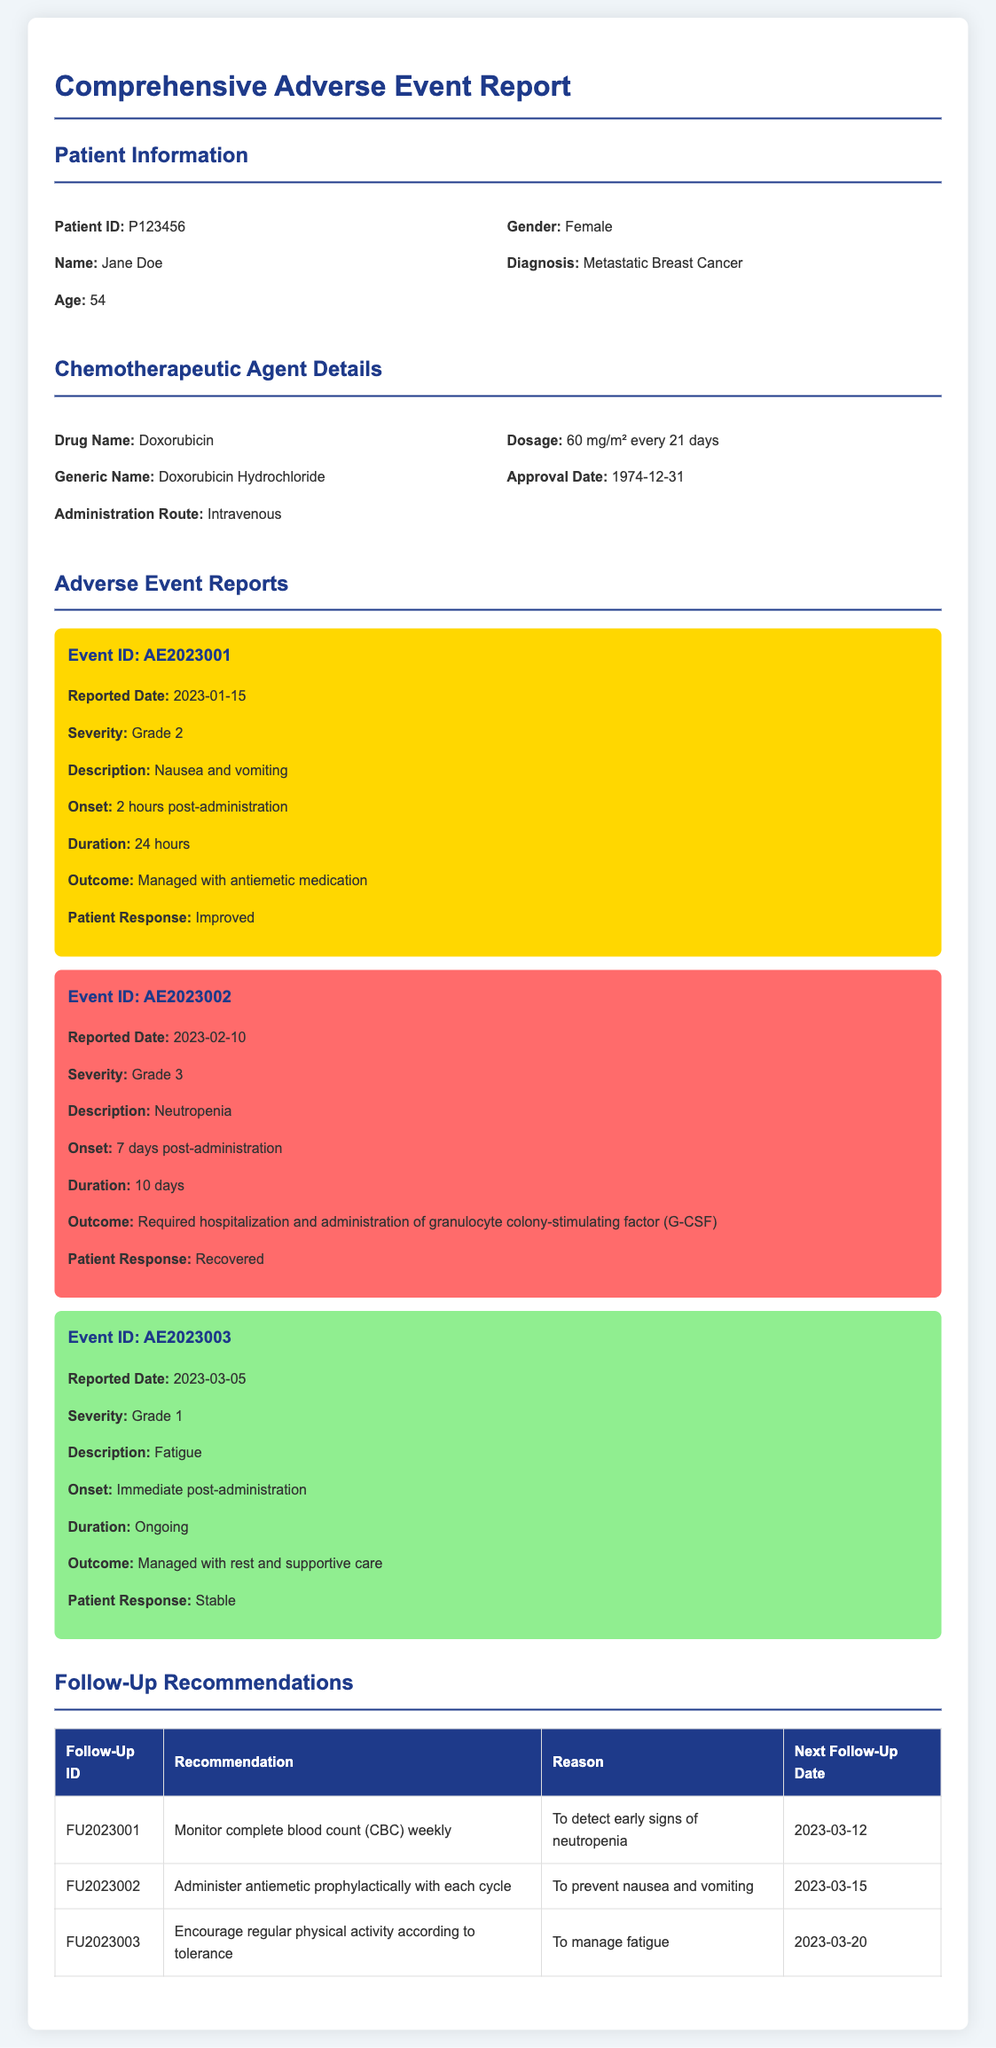What is the patient ID? The patient ID is a unique identifier for the patient, listed under Patient Information.
Answer: P123456 What is the drug name? The drug name is specified under the Chemotherapeutic Agent Details section.
Answer: Doxorubicin What was the reported date of the first adverse event? The reported date is found in the Adverse Event Reports section for the first event.
Answer: 2023-01-15 What is the duration of the neutropenia event? The duration can be found in the description of the neutropenia event under Adverse Event Reports.
Answer: 10 days What is the follow-up recommendation for neutropenia monitoring? The follow-up recommendation is listed in the Follow-Up Recommendations table.
Answer: Monitor complete blood count (CBC) weekly What grade was the severity of fatigue? The severity relates to the grade of the fatigue event listed in the Adverse Event Reports section.
Answer: Grade 1 What medication was administered for the management of neutropenia? The specific medication for managing neutropenia is detailed under the second adverse event in the report.
Answer: Granulocyte colony-stimulating factor (G-CSF) How often is the dosage of Doxorubicin administered? This information is provided in the Chemotherapeutic Agent Details section regarding the dosage schedule.
Answer: Every 21 days What is the next follow-up date for antiemetic prophylaxis? The next follow-up date is found in the Follow-Up Recommendations table for the antiemetic recommendation.
Answer: 2023-03-15 